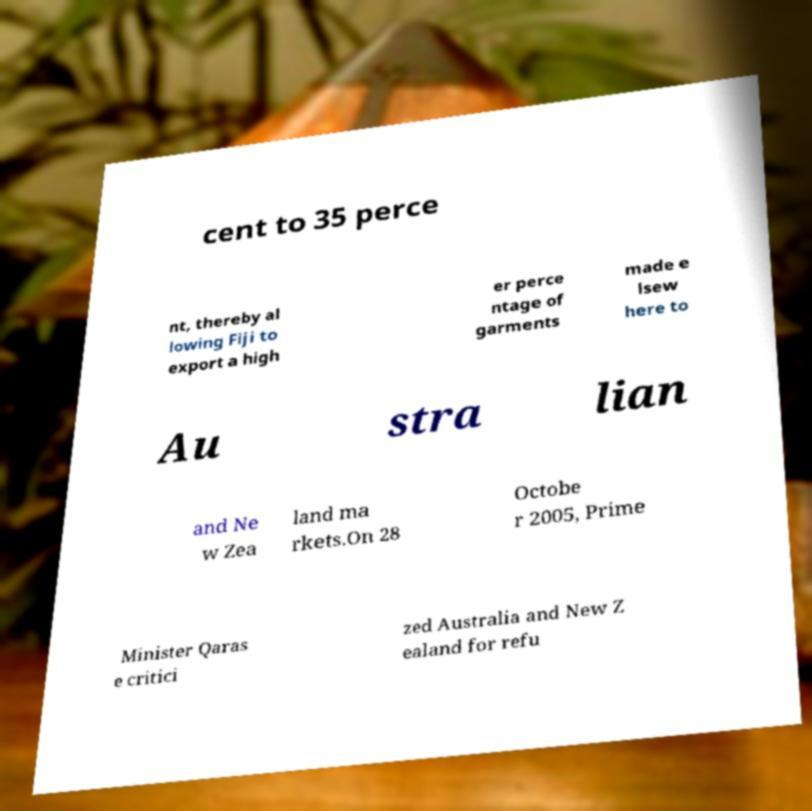Can you accurately transcribe the text from the provided image for me? cent to 35 perce nt, thereby al lowing Fiji to export a high er perce ntage of garments made e lsew here to Au stra lian and Ne w Zea land ma rkets.On 28 Octobe r 2005, Prime Minister Qaras e critici zed Australia and New Z ealand for refu 